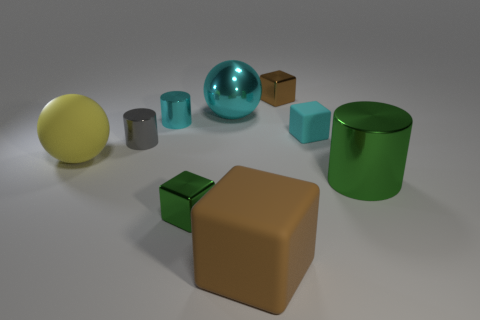Subtract all gray metallic cylinders. How many cylinders are left? 2 Subtract all green cubes. How many cubes are left? 3 Subtract all blue balls. How many brown blocks are left? 2 Subtract all brown spheres. Subtract all green shiny objects. How many objects are left? 7 Add 1 cyan objects. How many cyan objects are left? 4 Add 1 tiny gray metal objects. How many tiny gray metal objects exist? 2 Subtract 0 yellow cubes. How many objects are left? 9 Subtract all blocks. How many objects are left? 5 Subtract all green blocks. Subtract all cyan cylinders. How many blocks are left? 3 